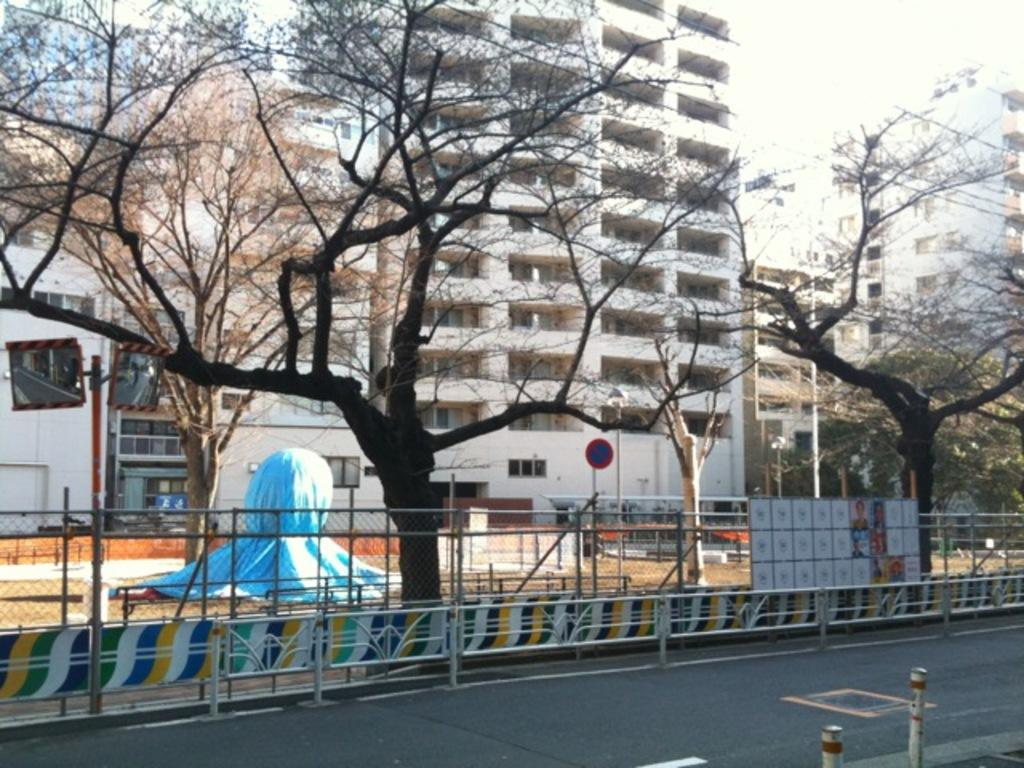What type of structures can be seen in the image? There are buildings in the image. What natural elements are present in the image? There are trees in the image. What type of barrier is visible in the image? There is a metal fence in the image. What is displayed on a board in the image? There are pictures on a board in the image. What part of the natural environment is visible in the image? The sky is visible in the image. How many ants are crawling on the buildings in the image? There are no ants present in the image. What change occurs in the image when you look at it from a different angle? The image does not change when viewed from different angles, as it is a static representation. 